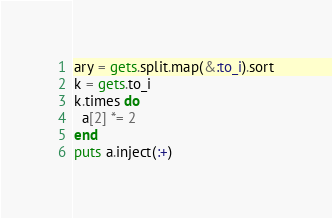Convert code to text. <code><loc_0><loc_0><loc_500><loc_500><_Ruby_>ary = gets.split.map(&:to_i).sort
k = gets.to_i
k.times do
  a[2] *= 2
end
puts a.inject(:+)</code> 